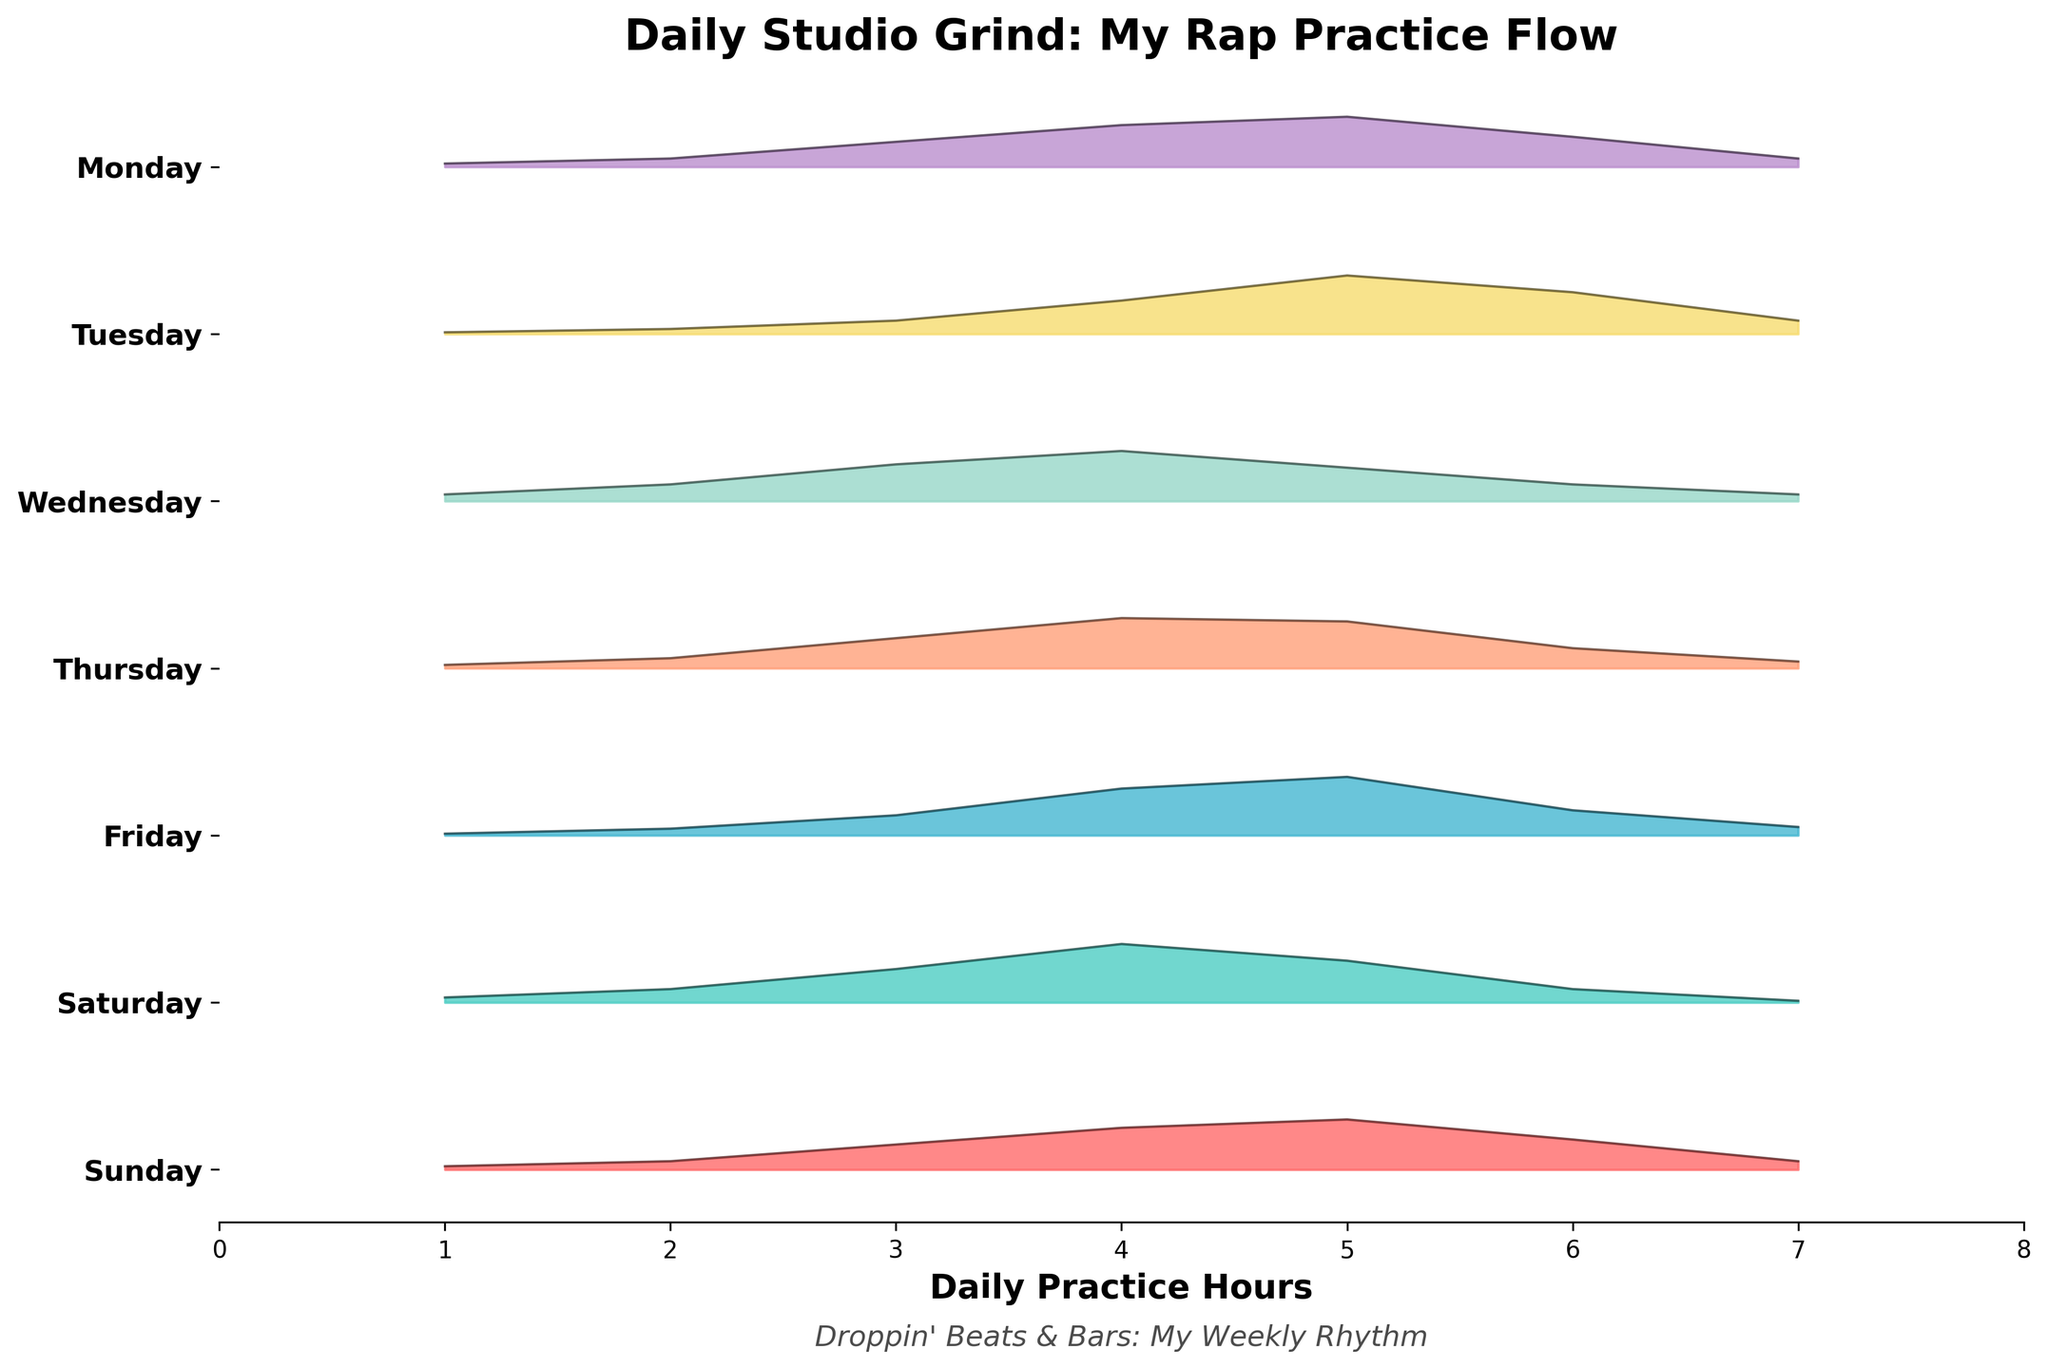What is the title of the figure? The title is located at the top of the figure, which often provides a summary or main focus. In this case, it reads "Daily Studio Grind: My Rap Practice Flow."
Answer: Daily Studio Grind: My Rap Practice Flow Which day appears to have the highest peak density for practice hours? To find the highest peak density, compare the peaks on each day. Wednesday's peak density reaches the highest point at the fifth hour.
Answer: Wednesday What color represents Thursday? Identify the color used for Thursday by referring to the color mapping in either the legend or the plot. Thursday is represented in orange.
Answer: Orange On which day is the distribution of practice hours most evenly spread out? Look for a more balanced spread of densities across different hours. Saturday shows a more even distribution compared to other days, with no single hour dominating excessively.
Answer: Saturday How do Tuesday's and Friday's practice distributions compare at 4 hours of practice? Compare the density values at the 4-hour mark for both Tuesday and Friday. Tuesday has a higher density at this hour.
Answer: Tuesday has a higher density How many hours of practice are most common on Monday? The most common practice hours correspond to the highest density peak on Monday, which is at the fifth hour.
Answer: 5 hours At what hour does the density start to decrease on Friday after reaching its peak? For Friday, find the hour at which the density peaks and then observe when it starts to decline. The decline begins after 4 hours of practice.
Answer: After 4 hours Which day shows the least variability in practice hours? Least variability can be inferred from less spread in peaks and densities. Tuesday shows a distinct peak at 4 hours with fewer significant variations around it.
Answer: Tuesday If you wanted to practice fewer than 3 hours, which day gives you the least density for such short practice periods? Compare the density values at 1 and 2 hours across all days to find the lowest values. Saturday has the lowest densities at these hours.
Answer: Saturday How does the distribution pattern on Sunday compare to that on Thursday? Analyze the density curves for both days. Sunday and Thursday both peak at 5 hours, but Sunday has a higher density at 6 hours compared to Thursday.
Answer: Sunday's peak at 6 hours is higher 